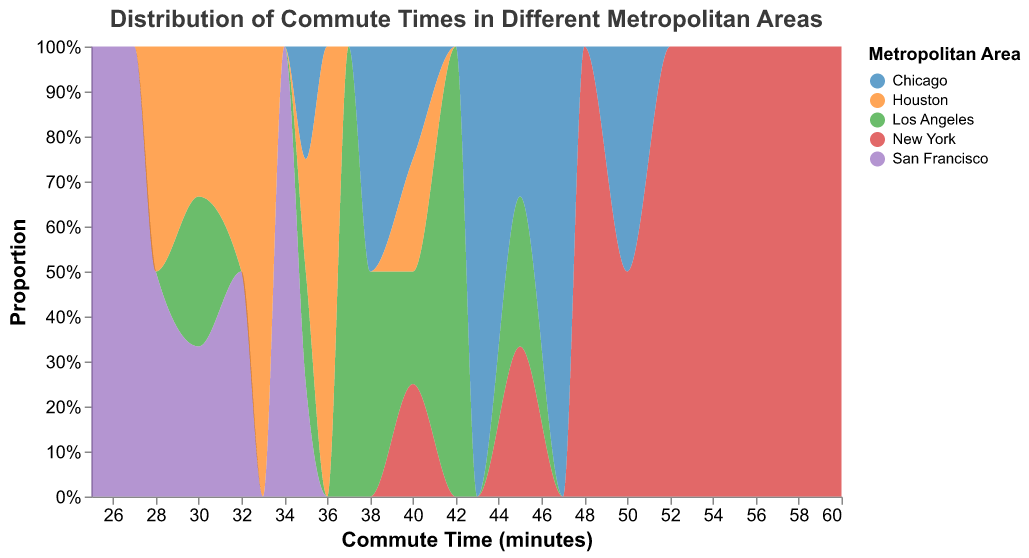What's the title of the figure? The title can be found at the top of the figure.
Answer: Distribution of Commute Times in Different Metropolitan Areas Which metropolitan area seems to have the longest commute times? By looking at the x-axis range covered by each area, New York extends to the highest commute times.
Answer: New York How does the commute time distribution for Los Angeles compare to Chicago? The Los Angeles distribution peaks around 35-45 minutes, while Chicago has a broader distribution between 35 and 50 minutes.
Answer: Los Angeles has a narrower commute distribution than Chicago What is the commute time range with the highest density for San Francisco? By observing the peak on the density plot for San Francisco, the commute time range of 25-35 minutes shows the highest density.
Answer: 25-35 minutes Which metropolitan area has the least variation in commute times? The area with the smallest spread on the x-axis indicates the least variation, which is San Francisco.
Answer: San Francisco What proportion of commutes in Houston are under 35 minutes? Observe the proportion of the density plot for Houston under the 35-minute mark.
Answer: Approximately 50% Is the median commute time higher in New York or Los Angeles? The median can be observed by finding the center of the density curves. New York’s median commute is around 50 minutes, while Los Angeles’s is around 37 minutes.
Answer: New York Which two metropolitan areas have overlapping commute time distributions? Examine where the density plots intersect; Chicago and Los Angeles show significant overlap around the 35-45 minute range.
Answer: Chicago and Los Angeles Calculate the average of the highest peak commute times for New York and Houston. Identify the highest peaks for New York (~50 minutes) and Houston (~33 minutes), then calculate their average: (50+33)/2 = 41.5 minutes.
Answer: 41.5 minutes 